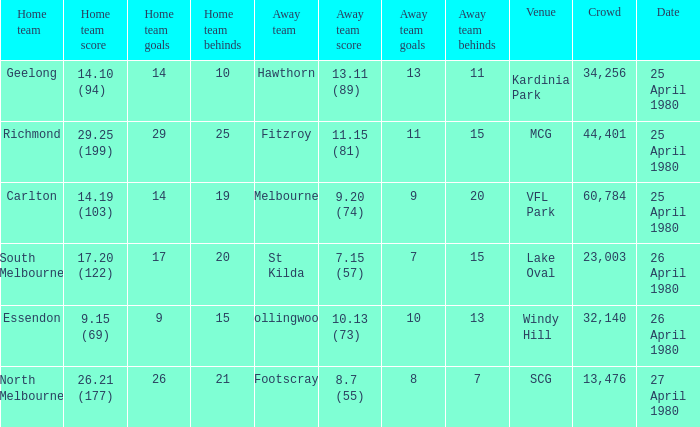Can you give me this table as a dict? {'header': ['Home team', 'Home team score', 'Home team goals', 'Home team behinds', 'Away team', 'Away team score', 'Away team goals', 'Away team behinds', 'Venue', 'Crowd', 'Date'], 'rows': [['Geelong', '14.10 (94)', '14', '10', 'Hawthorn', '13.11 (89)', '13', '11', 'Kardinia Park', '34,256', '25 April 1980'], ['Richmond', '29.25 (199)', '29', '25', 'Fitzroy', '11.15 (81)', '11', '15', 'MCG', '44,401', '25 April 1980'], ['Carlton', '14.19 (103)', '14', '19', 'Melbourne', '9.20 (74)', '9', '20', 'VFL Park', '60,784', '25 April 1980'], ['South Melbourne', '17.20 (122)', '17', '20', 'St Kilda', '7.15 (57)', '7', '15', 'Lake Oval', '23,003', '26 April 1980'], ['Essendon', '9.15 (69)', '9', '15', 'Collingwood', '10.13 (73)', '10', '13', 'Windy Hill', '32,140', '26 April 1980'], ['North Melbourne', '26.21 (177)', '26', '21', 'Footscray', '8.7 (55)', '8', '7', 'SCG', '13,476', '27 April 1980']]} When was the north melbourne home game held? 27 April 1980. 